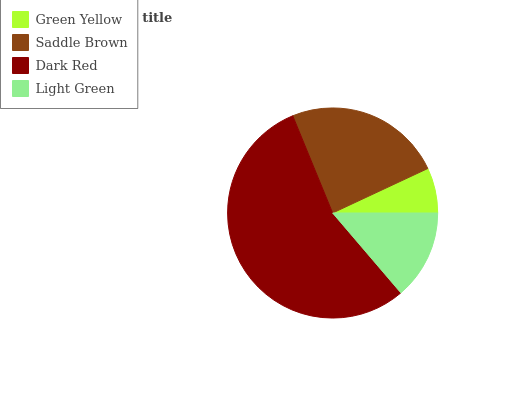Is Green Yellow the minimum?
Answer yes or no. Yes. Is Dark Red the maximum?
Answer yes or no. Yes. Is Saddle Brown the minimum?
Answer yes or no. No. Is Saddle Brown the maximum?
Answer yes or no. No. Is Saddle Brown greater than Green Yellow?
Answer yes or no. Yes. Is Green Yellow less than Saddle Brown?
Answer yes or no. Yes. Is Green Yellow greater than Saddle Brown?
Answer yes or no. No. Is Saddle Brown less than Green Yellow?
Answer yes or no. No. Is Saddle Brown the high median?
Answer yes or no. Yes. Is Light Green the low median?
Answer yes or no. Yes. Is Light Green the high median?
Answer yes or no. No. Is Green Yellow the low median?
Answer yes or no. No. 